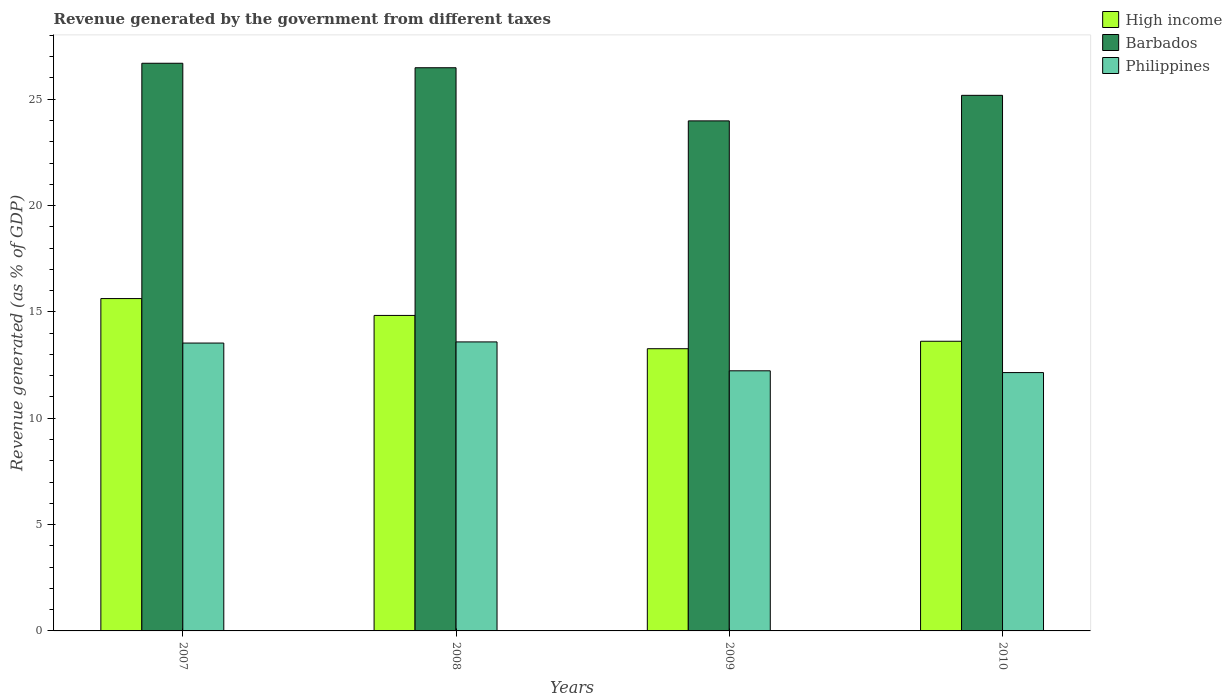How many different coloured bars are there?
Give a very brief answer. 3. How many groups of bars are there?
Provide a short and direct response. 4. Are the number of bars per tick equal to the number of legend labels?
Ensure brevity in your answer.  Yes. How many bars are there on the 3rd tick from the right?
Your response must be concise. 3. What is the revenue generated by the government in Philippines in 2009?
Offer a very short reply. 12.23. Across all years, what is the maximum revenue generated by the government in Philippines?
Provide a succinct answer. 13.59. Across all years, what is the minimum revenue generated by the government in High income?
Ensure brevity in your answer.  13.27. In which year was the revenue generated by the government in Philippines maximum?
Offer a terse response. 2008. What is the total revenue generated by the government in Philippines in the graph?
Provide a succinct answer. 51.5. What is the difference between the revenue generated by the government in Barbados in 2007 and that in 2008?
Offer a terse response. 0.21. What is the difference between the revenue generated by the government in High income in 2008 and the revenue generated by the government in Barbados in 2007?
Make the answer very short. -11.86. What is the average revenue generated by the government in High income per year?
Make the answer very short. 14.34. In the year 2009, what is the difference between the revenue generated by the government in High income and revenue generated by the government in Barbados?
Your response must be concise. -10.71. What is the ratio of the revenue generated by the government in Barbados in 2009 to that in 2010?
Offer a very short reply. 0.95. Is the difference between the revenue generated by the government in High income in 2007 and 2009 greater than the difference between the revenue generated by the government in Barbados in 2007 and 2009?
Make the answer very short. No. What is the difference between the highest and the second highest revenue generated by the government in Philippines?
Ensure brevity in your answer.  0.05. What is the difference between the highest and the lowest revenue generated by the government in High income?
Offer a terse response. 2.36. In how many years, is the revenue generated by the government in High income greater than the average revenue generated by the government in High income taken over all years?
Keep it short and to the point. 2. What does the 2nd bar from the left in 2007 represents?
Offer a very short reply. Barbados. What does the 2nd bar from the right in 2010 represents?
Make the answer very short. Barbados. How many bars are there?
Your response must be concise. 12. Are all the bars in the graph horizontal?
Your answer should be very brief. No. How many years are there in the graph?
Make the answer very short. 4. Are the values on the major ticks of Y-axis written in scientific E-notation?
Your answer should be very brief. No. Does the graph contain any zero values?
Provide a succinct answer. No. How are the legend labels stacked?
Ensure brevity in your answer.  Vertical. What is the title of the graph?
Your answer should be very brief. Revenue generated by the government from different taxes. What is the label or title of the X-axis?
Provide a succinct answer. Years. What is the label or title of the Y-axis?
Make the answer very short. Revenue generated (as % of GDP). What is the Revenue generated (as % of GDP) in High income in 2007?
Ensure brevity in your answer.  15.63. What is the Revenue generated (as % of GDP) of Barbados in 2007?
Provide a succinct answer. 26.69. What is the Revenue generated (as % of GDP) in Philippines in 2007?
Give a very brief answer. 13.54. What is the Revenue generated (as % of GDP) of High income in 2008?
Provide a short and direct response. 14.83. What is the Revenue generated (as % of GDP) in Barbados in 2008?
Your response must be concise. 26.48. What is the Revenue generated (as % of GDP) in Philippines in 2008?
Your response must be concise. 13.59. What is the Revenue generated (as % of GDP) in High income in 2009?
Your response must be concise. 13.27. What is the Revenue generated (as % of GDP) in Barbados in 2009?
Make the answer very short. 23.98. What is the Revenue generated (as % of GDP) of Philippines in 2009?
Keep it short and to the point. 12.23. What is the Revenue generated (as % of GDP) of High income in 2010?
Your answer should be compact. 13.62. What is the Revenue generated (as % of GDP) of Barbados in 2010?
Give a very brief answer. 25.18. What is the Revenue generated (as % of GDP) in Philippines in 2010?
Your answer should be compact. 12.15. Across all years, what is the maximum Revenue generated (as % of GDP) of High income?
Provide a succinct answer. 15.63. Across all years, what is the maximum Revenue generated (as % of GDP) of Barbados?
Give a very brief answer. 26.69. Across all years, what is the maximum Revenue generated (as % of GDP) of Philippines?
Provide a succinct answer. 13.59. Across all years, what is the minimum Revenue generated (as % of GDP) of High income?
Your answer should be very brief. 13.27. Across all years, what is the minimum Revenue generated (as % of GDP) of Barbados?
Provide a short and direct response. 23.98. Across all years, what is the minimum Revenue generated (as % of GDP) of Philippines?
Provide a succinct answer. 12.15. What is the total Revenue generated (as % of GDP) in High income in the graph?
Offer a very short reply. 57.35. What is the total Revenue generated (as % of GDP) in Barbados in the graph?
Ensure brevity in your answer.  102.33. What is the total Revenue generated (as % of GDP) in Philippines in the graph?
Give a very brief answer. 51.5. What is the difference between the Revenue generated (as % of GDP) in High income in 2007 and that in 2008?
Your answer should be very brief. 0.79. What is the difference between the Revenue generated (as % of GDP) of Barbados in 2007 and that in 2008?
Your answer should be compact. 0.21. What is the difference between the Revenue generated (as % of GDP) in Philippines in 2007 and that in 2008?
Provide a short and direct response. -0.05. What is the difference between the Revenue generated (as % of GDP) in High income in 2007 and that in 2009?
Offer a very short reply. 2.36. What is the difference between the Revenue generated (as % of GDP) of Barbados in 2007 and that in 2009?
Your answer should be compact. 2.71. What is the difference between the Revenue generated (as % of GDP) in Philippines in 2007 and that in 2009?
Your answer should be very brief. 1.3. What is the difference between the Revenue generated (as % of GDP) in High income in 2007 and that in 2010?
Your answer should be very brief. 2.01. What is the difference between the Revenue generated (as % of GDP) of Barbados in 2007 and that in 2010?
Keep it short and to the point. 1.51. What is the difference between the Revenue generated (as % of GDP) in Philippines in 2007 and that in 2010?
Give a very brief answer. 1.39. What is the difference between the Revenue generated (as % of GDP) of High income in 2008 and that in 2009?
Your response must be concise. 1.56. What is the difference between the Revenue generated (as % of GDP) in Barbados in 2008 and that in 2009?
Give a very brief answer. 2.5. What is the difference between the Revenue generated (as % of GDP) in Philippines in 2008 and that in 2009?
Offer a terse response. 1.36. What is the difference between the Revenue generated (as % of GDP) in High income in 2008 and that in 2010?
Keep it short and to the point. 1.21. What is the difference between the Revenue generated (as % of GDP) in Barbados in 2008 and that in 2010?
Your answer should be compact. 1.3. What is the difference between the Revenue generated (as % of GDP) in Philippines in 2008 and that in 2010?
Provide a short and direct response. 1.44. What is the difference between the Revenue generated (as % of GDP) of High income in 2009 and that in 2010?
Provide a succinct answer. -0.35. What is the difference between the Revenue generated (as % of GDP) in Barbados in 2009 and that in 2010?
Offer a terse response. -1.2. What is the difference between the Revenue generated (as % of GDP) in Philippines in 2009 and that in 2010?
Your answer should be very brief. 0.08. What is the difference between the Revenue generated (as % of GDP) of High income in 2007 and the Revenue generated (as % of GDP) of Barbados in 2008?
Give a very brief answer. -10.85. What is the difference between the Revenue generated (as % of GDP) of High income in 2007 and the Revenue generated (as % of GDP) of Philippines in 2008?
Provide a short and direct response. 2.04. What is the difference between the Revenue generated (as % of GDP) of Barbados in 2007 and the Revenue generated (as % of GDP) of Philippines in 2008?
Make the answer very short. 13.1. What is the difference between the Revenue generated (as % of GDP) in High income in 2007 and the Revenue generated (as % of GDP) in Barbados in 2009?
Give a very brief answer. -8.35. What is the difference between the Revenue generated (as % of GDP) in High income in 2007 and the Revenue generated (as % of GDP) in Philippines in 2009?
Your answer should be very brief. 3.4. What is the difference between the Revenue generated (as % of GDP) in Barbados in 2007 and the Revenue generated (as % of GDP) in Philippines in 2009?
Make the answer very short. 14.46. What is the difference between the Revenue generated (as % of GDP) in High income in 2007 and the Revenue generated (as % of GDP) in Barbados in 2010?
Provide a succinct answer. -9.56. What is the difference between the Revenue generated (as % of GDP) in High income in 2007 and the Revenue generated (as % of GDP) in Philippines in 2010?
Offer a terse response. 3.48. What is the difference between the Revenue generated (as % of GDP) in Barbados in 2007 and the Revenue generated (as % of GDP) in Philippines in 2010?
Your response must be concise. 14.54. What is the difference between the Revenue generated (as % of GDP) in High income in 2008 and the Revenue generated (as % of GDP) in Barbados in 2009?
Your answer should be compact. -9.15. What is the difference between the Revenue generated (as % of GDP) of High income in 2008 and the Revenue generated (as % of GDP) of Philippines in 2009?
Provide a short and direct response. 2.6. What is the difference between the Revenue generated (as % of GDP) in Barbados in 2008 and the Revenue generated (as % of GDP) in Philippines in 2009?
Your answer should be very brief. 14.25. What is the difference between the Revenue generated (as % of GDP) of High income in 2008 and the Revenue generated (as % of GDP) of Barbados in 2010?
Ensure brevity in your answer.  -10.35. What is the difference between the Revenue generated (as % of GDP) in High income in 2008 and the Revenue generated (as % of GDP) in Philippines in 2010?
Give a very brief answer. 2.69. What is the difference between the Revenue generated (as % of GDP) of Barbados in 2008 and the Revenue generated (as % of GDP) of Philippines in 2010?
Ensure brevity in your answer.  14.33. What is the difference between the Revenue generated (as % of GDP) in High income in 2009 and the Revenue generated (as % of GDP) in Barbados in 2010?
Your answer should be very brief. -11.91. What is the difference between the Revenue generated (as % of GDP) in High income in 2009 and the Revenue generated (as % of GDP) in Philippines in 2010?
Make the answer very short. 1.12. What is the difference between the Revenue generated (as % of GDP) in Barbados in 2009 and the Revenue generated (as % of GDP) in Philippines in 2010?
Your answer should be compact. 11.83. What is the average Revenue generated (as % of GDP) in High income per year?
Provide a succinct answer. 14.34. What is the average Revenue generated (as % of GDP) in Barbados per year?
Your response must be concise. 25.58. What is the average Revenue generated (as % of GDP) of Philippines per year?
Give a very brief answer. 12.88. In the year 2007, what is the difference between the Revenue generated (as % of GDP) of High income and Revenue generated (as % of GDP) of Barbados?
Keep it short and to the point. -11.06. In the year 2007, what is the difference between the Revenue generated (as % of GDP) in High income and Revenue generated (as % of GDP) in Philippines?
Offer a very short reply. 2.09. In the year 2007, what is the difference between the Revenue generated (as % of GDP) in Barbados and Revenue generated (as % of GDP) in Philippines?
Your answer should be very brief. 13.16. In the year 2008, what is the difference between the Revenue generated (as % of GDP) of High income and Revenue generated (as % of GDP) of Barbados?
Make the answer very short. -11.65. In the year 2008, what is the difference between the Revenue generated (as % of GDP) in High income and Revenue generated (as % of GDP) in Philippines?
Make the answer very short. 1.24. In the year 2008, what is the difference between the Revenue generated (as % of GDP) of Barbados and Revenue generated (as % of GDP) of Philippines?
Your answer should be compact. 12.89. In the year 2009, what is the difference between the Revenue generated (as % of GDP) in High income and Revenue generated (as % of GDP) in Barbados?
Make the answer very short. -10.71. In the year 2009, what is the difference between the Revenue generated (as % of GDP) of High income and Revenue generated (as % of GDP) of Philippines?
Ensure brevity in your answer.  1.04. In the year 2009, what is the difference between the Revenue generated (as % of GDP) in Barbados and Revenue generated (as % of GDP) in Philippines?
Keep it short and to the point. 11.75. In the year 2010, what is the difference between the Revenue generated (as % of GDP) in High income and Revenue generated (as % of GDP) in Barbados?
Offer a very short reply. -11.56. In the year 2010, what is the difference between the Revenue generated (as % of GDP) of High income and Revenue generated (as % of GDP) of Philippines?
Ensure brevity in your answer.  1.47. In the year 2010, what is the difference between the Revenue generated (as % of GDP) in Barbados and Revenue generated (as % of GDP) in Philippines?
Your answer should be very brief. 13.04. What is the ratio of the Revenue generated (as % of GDP) in High income in 2007 to that in 2008?
Provide a succinct answer. 1.05. What is the ratio of the Revenue generated (as % of GDP) in Barbados in 2007 to that in 2008?
Offer a terse response. 1.01. What is the ratio of the Revenue generated (as % of GDP) of High income in 2007 to that in 2009?
Your answer should be compact. 1.18. What is the ratio of the Revenue generated (as % of GDP) in Barbados in 2007 to that in 2009?
Keep it short and to the point. 1.11. What is the ratio of the Revenue generated (as % of GDP) in Philippines in 2007 to that in 2009?
Offer a terse response. 1.11. What is the ratio of the Revenue generated (as % of GDP) in High income in 2007 to that in 2010?
Your answer should be very brief. 1.15. What is the ratio of the Revenue generated (as % of GDP) of Barbados in 2007 to that in 2010?
Offer a terse response. 1.06. What is the ratio of the Revenue generated (as % of GDP) in Philippines in 2007 to that in 2010?
Your response must be concise. 1.11. What is the ratio of the Revenue generated (as % of GDP) in High income in 2008 to that in 2009?
Give a very brief answer. 1.12. What is the ratio of the Revenue generated (as % of GDP) of Barbados in 2008 to that in 2009?
Your response must be concise. 1.1. What is the ratio of the Revenue generated (as % of GDP) in High income in 2008 to that in 2010?
Ensure brevity in your answer.  1.09. What is the ratio of the Revenue generated (as % of GDP) in Barbados in 2008 to that in 2010?
Your answer should be compact. 1.05. What is the ratio of the Revenue generated (as % of GDP) in Philippines in 2008 to that in 2010?
Ensure brevity in your answer.  1.12. What is the ratio of the Revenue generated (as % of GDP) of High income in 2009 to that in 2010?
Your answer should be compact. 0.97. What is the ratio of the Revenue generated (as % of GDP) in Barbados in 2009 to that in 2010?
Give a very brief answer. 0.95. What is the difference between the highest and the second highest Revenue generated (as % of GDP) in High income?
Give a very brief answer. 0.79. What is the difference between the highest and the second highest Revenue generated (as % of GDP) in Barbados?
Provide a succinct answer. 0.21. What is the difference between the highest and the second highest Revenue generated (as % of GDP) of Philippines?
Offer a very short reply. 0.05. What is the difference between the highest and the lowest Revenue generated (as % of GDP) in High income?
Keep it short and to the point. 2.36. What is the difference between the highest and the lowest Revenue generated (as % of GDP) of Barbados?
Provide a short and direct response. 2.71. What is the difference between the highest and the lowest Revenue generated (as % of GDP) in Philippines?
Ensure brevity in your answer.  1.44. 